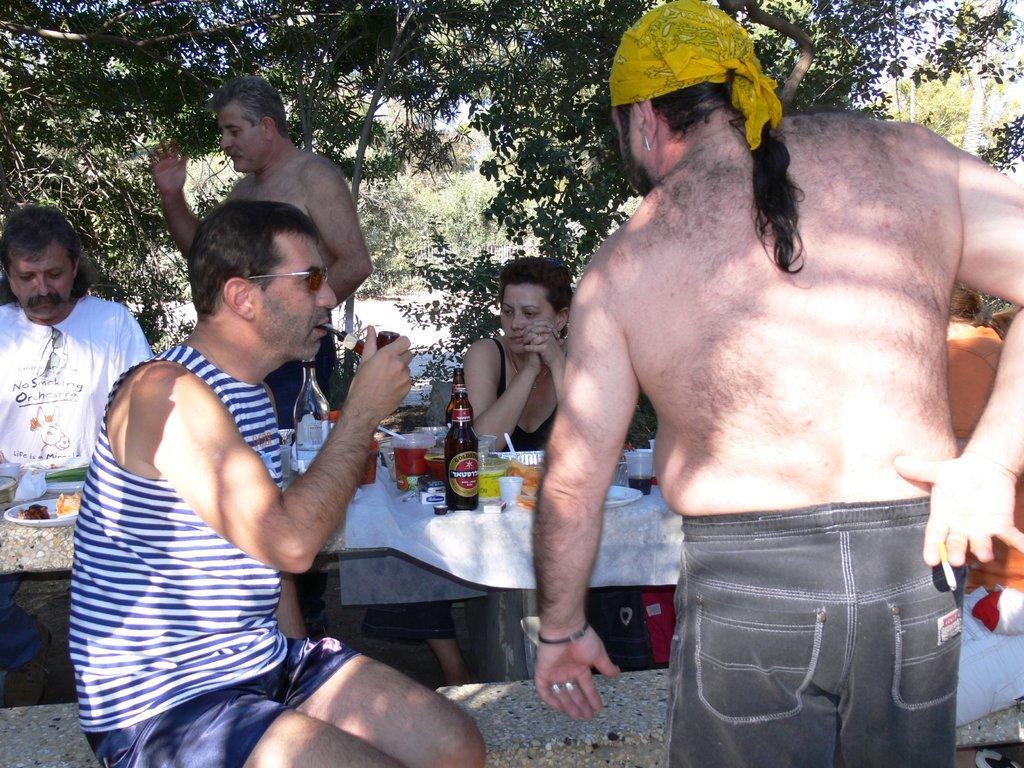Please provide a concise description of this image. In an open area there is a marble table and a marble bench,group of people are sitting around the table. On the table there are some drinks and food items are placed. behind the people there are many trees. 